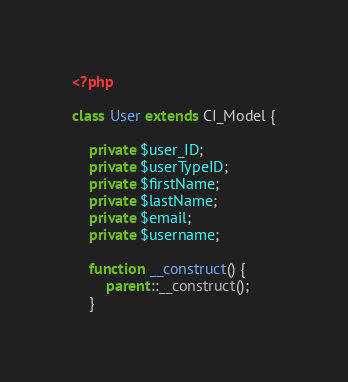Convert code to text. <code><loc_0><loc_0><loc_500><loc_500><_PHP_><?php

class User extends CI_Model {

    private $user_ID;
    private $userTypeID;
    private $firstName;
    private $lastName;
    private $email;
    private $username;

    function __construct() {
        parent::__construct();
    }
</code> 